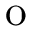<formula> <loc_0><loc_0><loc_500><loc_500>o</formula> 